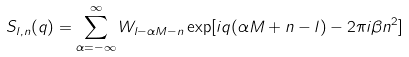<formula> <loc_0><loc_0><loc_500><loc_500>S _ { l , n } ( q ) = \sum _ { \alpha = - \infty } ^ { \infty } W _ { l - \alpha M - n } \exp [ i q ( \alpha M + n - l ) - 2 \pi i \beta n ^ { 2 } ]</formula> 